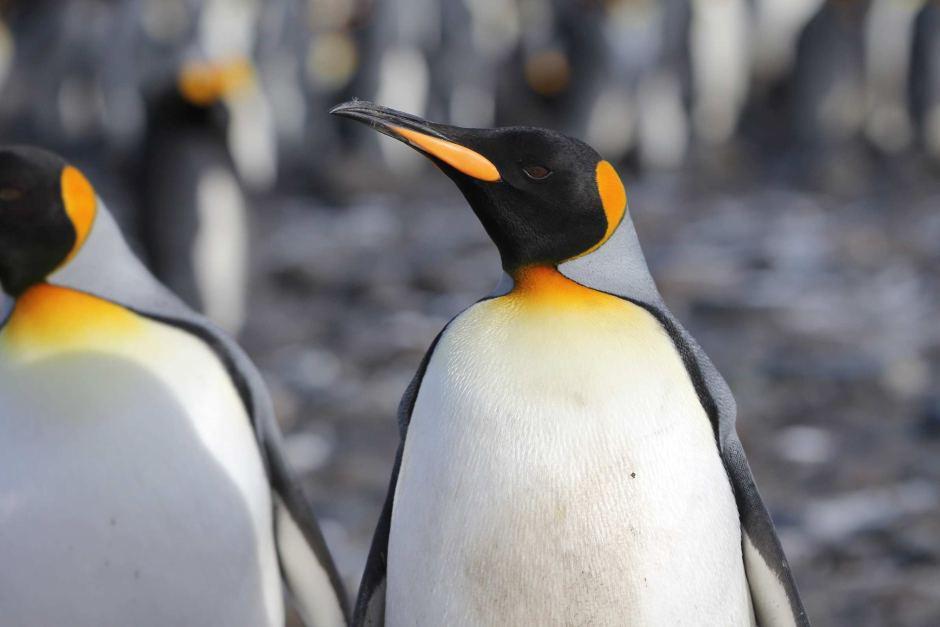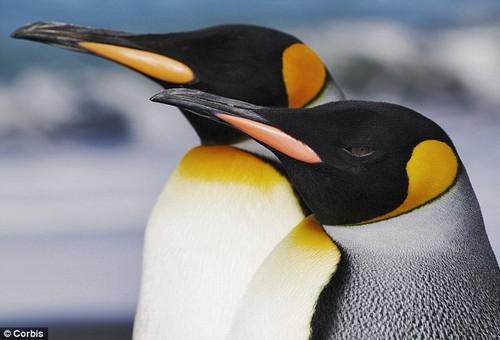The first image is the image on the left, the second image is the image on the right. Given the left and right images, does the statement "There are two penguins with crossed beaks in at least one of the images." hold true? Answer yes or no. No. 